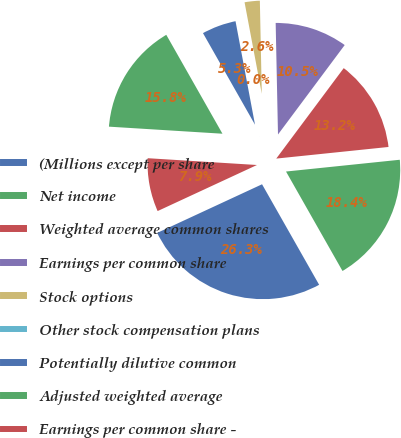Convert chart to OTSL. <chart><loc_0><loc_0><loc_500><loc_500><pie_chart><fcel>(Millions except per share<fcel>Net income<fcel>Weighted average common shares<fcel>Earnings per common share<fcel>Stock options<fcel>Other stock compensation plans<fcel>Potentially dilutive common<fcel>Adjusted weighted average<fcel>Earnings per common share -<nl><fcel>26.31%<fcel>18.42%<fcel>13.16%<fcel>10.53%<fcel>2.63%<fcel>0.0%<fcel>5.26%<fcel>15.79%<fcel>7.9%<nl></chart> 